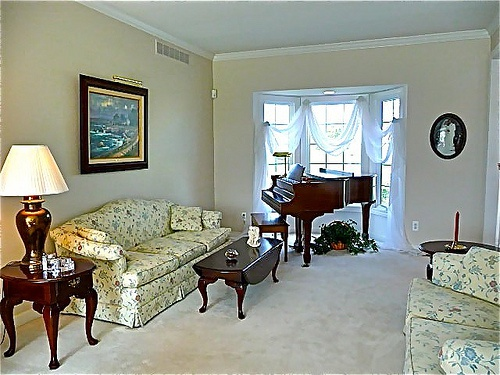Describe the objects in this image and their specific colors. I can see couch in lightgray, darkgray, olive, and beige tones, couch in lightgray, darkgray, beige, and gray tones, and potted plant in lightgray, black, gray, white, and darkgray tones in this image. 